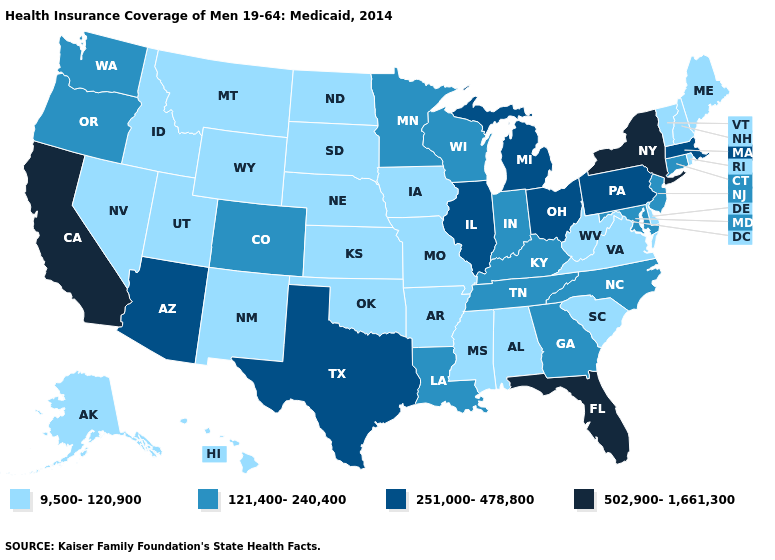Among the states that border California , does Nevada have the highest value?
Quick response, please. No. Which states have the lowest value in the USA?
Give a very brief answer. Alabama, Alaska, Arkansas, Delaware, Hawaii, Idaho, Iowa, Kansas, Maine, Mississippi, Missouri, Montana, Nebraska, Nevada, New Hampshire, New Mexico, North Dakota, Oklahoma, Rhode Island, South Carolina, South Dakota, Utah, Vermont, Virginia, West Virginia, Wyoming. What is the highest value in the USA?
Be succinct. 502,900-1,661,300. Among the states that border South Dakota , does Minnesota have the highest value?
Give a very brief answer. Yes. Name the states that have a value in the range 251,000-478,800?
Answer briefly. Arizona, Illinois, Massachusetts, Michigan, Ohio, Pennsylvania, Texas. How many symbols are there in the legend?
Give a very brief answer. 4. Does Illinois have a lower value than California?
Give a very brief answer. Yes. Name the states that have a value in the range 9,500-120,900?
Give a very brief answer. Alabama, Alaska, Arkansas, Delaware, Hawaii, Idaho, Iowa, Kansas, Maine, Mississippi, Missouri, Montana, Nebraska, Nevada, New Hampshire, New Mexico, North Dakota, Oklahoma, Rhode Island, South Carolina, South Dakota, Utah, Vermont, Virginia, West Virginia, Wyoming. Which states have the highest value in the USA?
Answer briefly. California, Florida, New York. How many symbols are there in the legend?
Answer briefly. 4. What is the value of Oklahoma?
Keep it brief. 9,500-120,900. Is the legend a continuous bar?
Write a very short answer. No. What is the value of Iowa?
Concise answer only. 9,500-120,900. What is the value of Arkansas?
Short answer required. 9,500-120,900. 